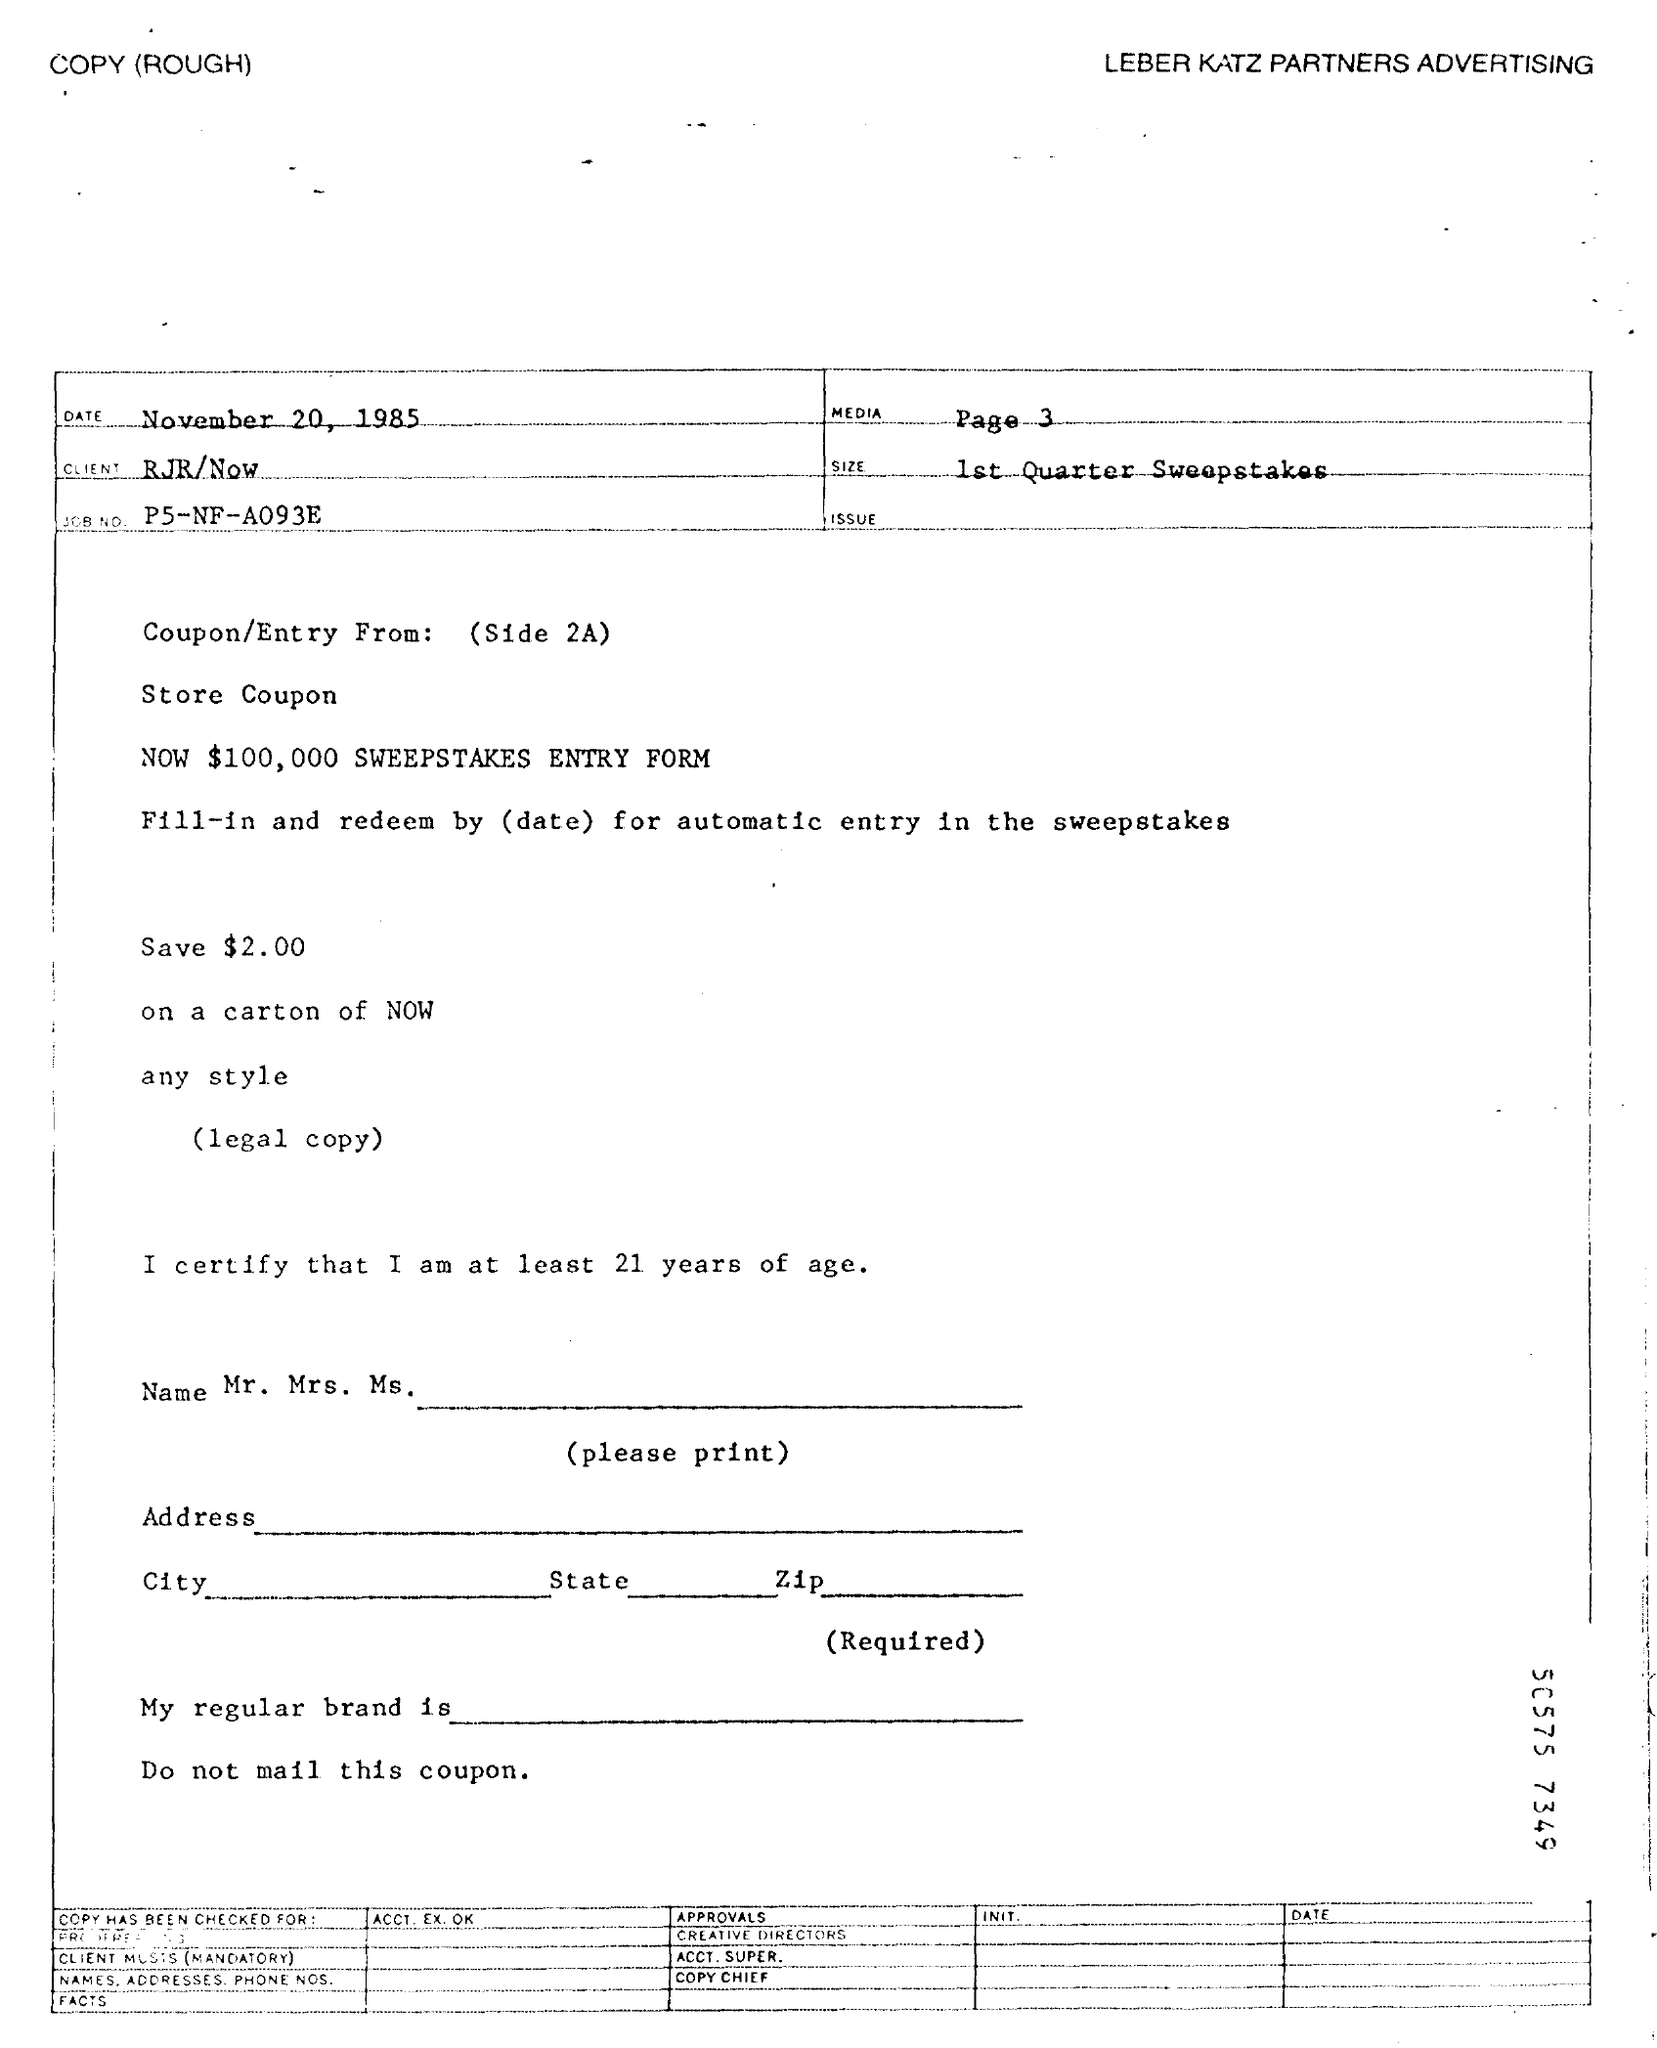Outline some significant characteristics in this image. On November 20, 1985, the date is known. The Job No. is P5-NF-A093E. What is the media?" is a question that has been the subject of much debate and discussion. On page 3 of this discourse, we will explore the various definitions and characteristics of the media in greater detail. Please provide the size of the first quarter sweepstakes. 